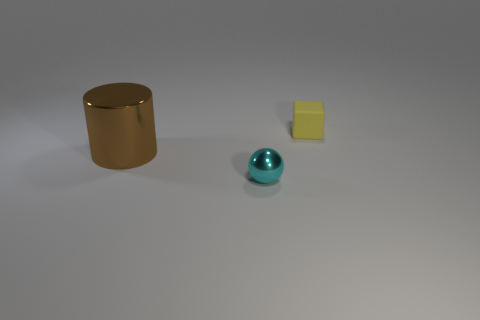Add 1 green metal cubes. How many objects exist? 4 Subtract 1 cubes. How many cubes are left? 0 Subtract all large brown things. Subtract all matte cubes. How many objects are left? 1 Add 1 yellow objects. How many yellow objects are left? 2 Add 1 large brown shiny cylinders. How many large brown shiny cylinders exist? 2 Subtract 0 cyan cubes. How many objects are left? 3 Subtract all cubes. How many objects are left? 2 Subtract all gray blocks. Subtract all gray balls. How many blocks are left? 1 